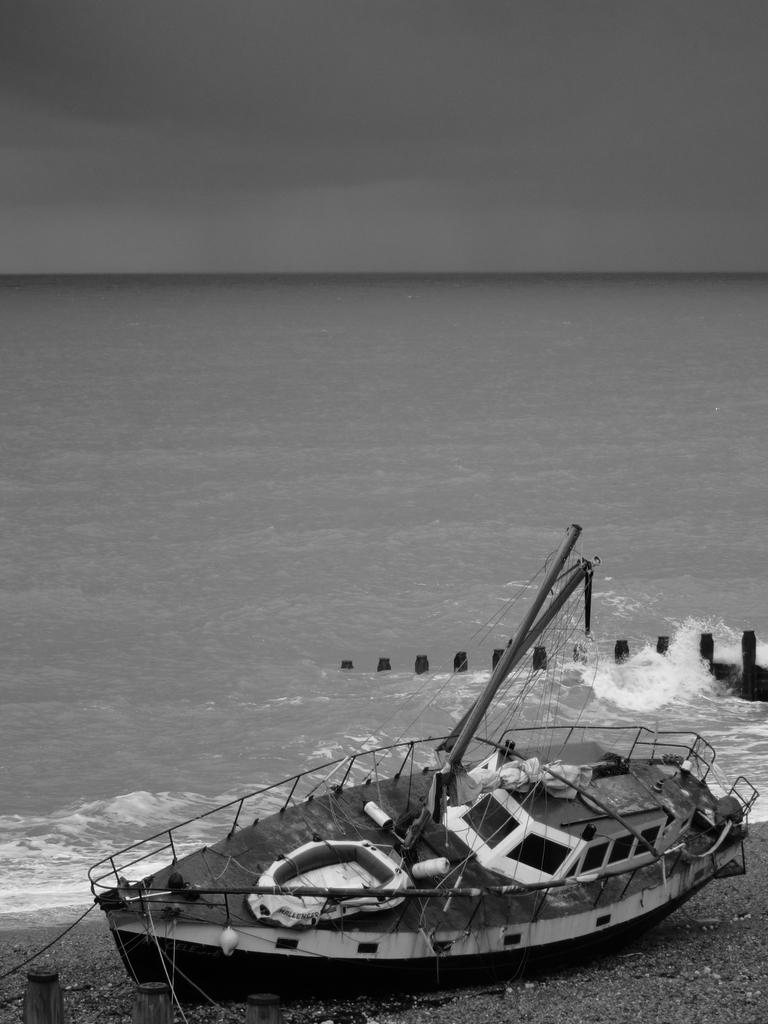What is the color scheme of the image? The image is black and white. What is the main subject of the image? There is a ship in the image. Where is the ship located in the image? The ship is on the sea shore. What other objects can be seen in the image? There are wooden poles and a large water body in the image. What is the condition of the sky in the image? The sky is visible in the image and appears cloudy. How many ladybugs can be seen on the ship in the image? There are no ladybugs present in the image; it features a ship on the sea shore with a cloudy sky. What letters are written on the wooden poles in the image? There are no letters visible on the wooden poles in the image. 